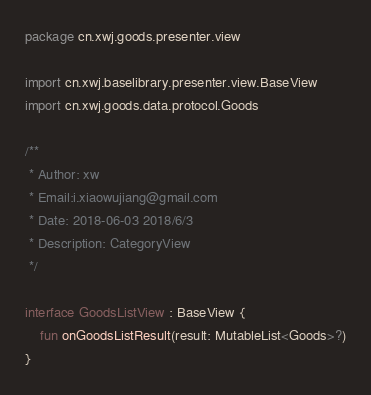Convert code to text. <code><loc_0><loc_0><loc_500><loc_500><_Kotlin_>package cn.xwj.goods.presenter.view

import cn.xwj.baselibrary.presenter.view.BaseView
import cn.xwj.goods.data.protocol.Goods

/**
 * Author: xw
 * Email:i.xiaowujiang@gmail.com
 * Date: 2018-06-03 2018/6/3
 * Description: CategoryView
 */

interface GoodsListView : BaseView {
    fun onGoodsListResult(result: MutableList<Goods>?)
}</code> 